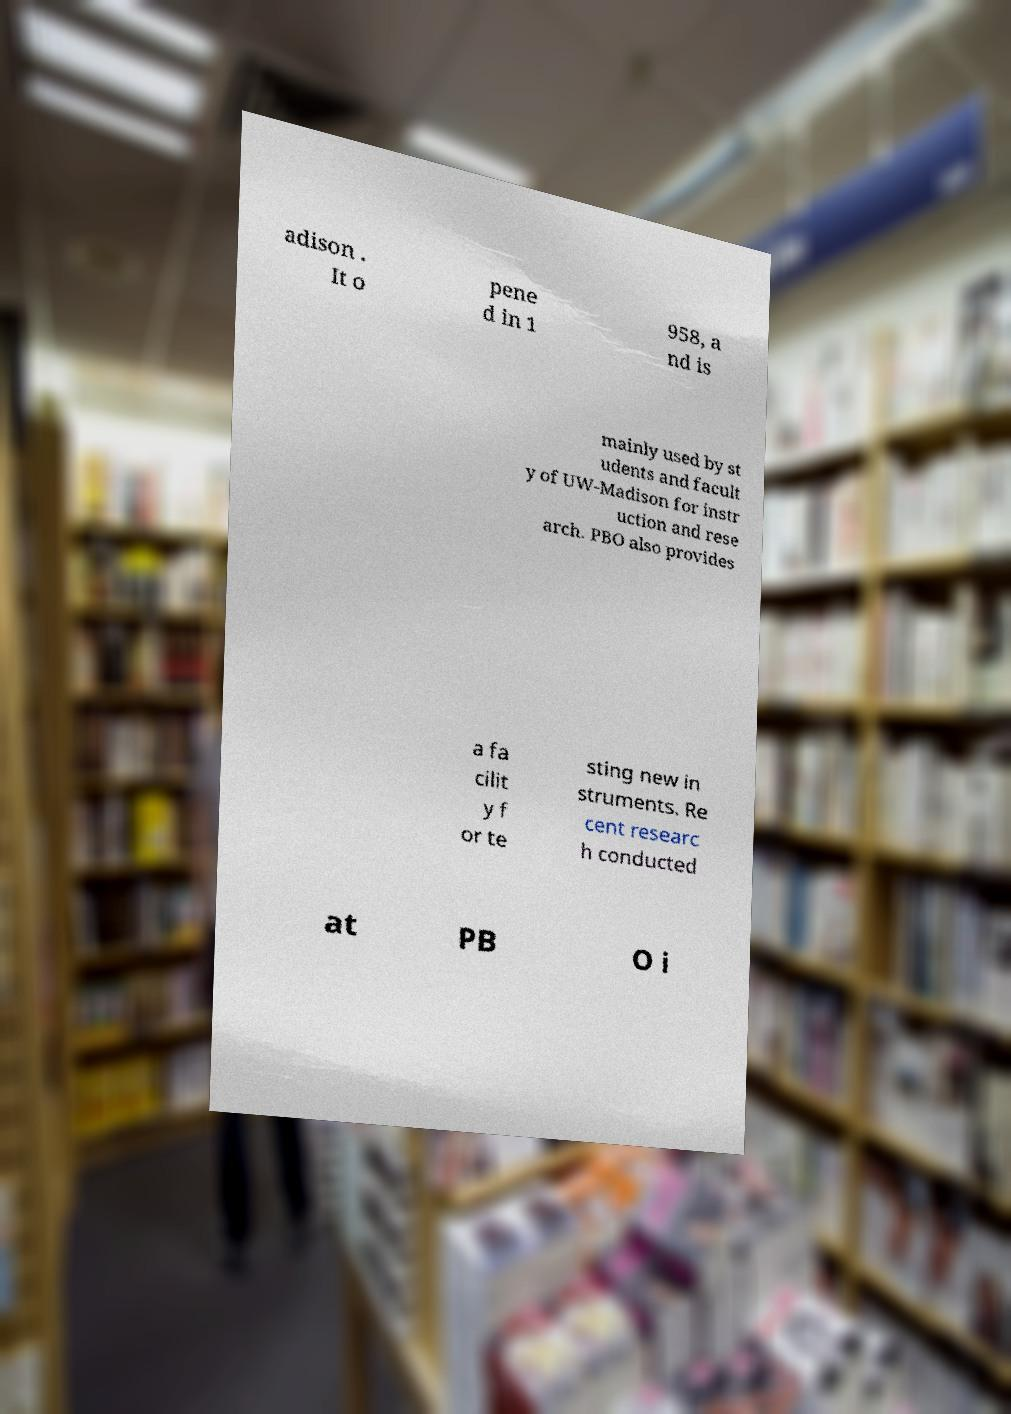Please identify and transcribe the text found in this image. adison . It o pene d in 1 958, a nd is mainly used by st udents and facult y of UW-Madison for instr uction and rese arch. PBO also provides a fa cilit y f or te sting new in struments. Re cent researc h conducted at PB O i 